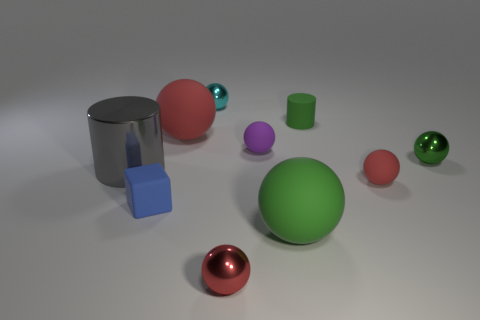Is there anything else that has the same color as the small rubber cube?
Give a very brief answer. No. Does the tiny cyan thing have the same shape as the small purple object?
Give a very brief answer. Yes. There is a large object that is the same color as the tiny cylinder; what material is it?
Your answer should be compact. Rubber. There is a red rubber thing right of the red metallic thing; is its shape the same as the red metallic object?
Keep it short and to the point. Yes. What number of things are green objects or cyan metallic things?
Provide a short and direct response. 4. Does the big sphere that is on the right side of the small cyan object have the same material as the big gray cylinder?
Provide a short and direct response. No. How big is the gray shiny cylinder?
Provide a short and direct response. Large. The big object that is the same color as the tiny matte cylinder is what shape?
Keep it short and to the point. Sphere. What number of blocks are either tiny green objects or large green matte objects?
Offer a very short reply. 0. Are there the same number of blue cubes behind the tiny cyan sphere and tiny cyan things that are to the right of the big metallic object?
Offer a very short reply. No. 